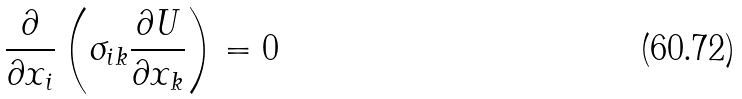<formula> <loc_0><loc_0><loc_500><loc_500>\frac { \partial } { \partial x _ { i } } \left ( \sigma _ { i k } \frac { \partial U } { \partial x _ { k } } \right ) & = 0</formula> 